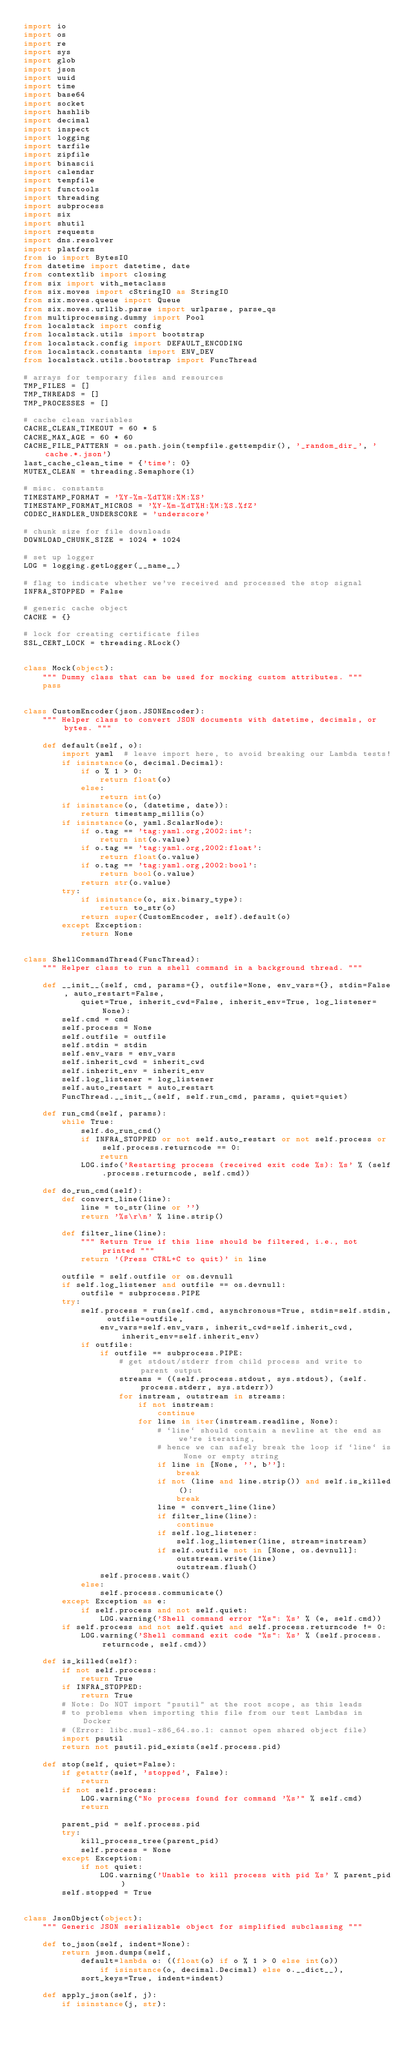Convert code to text. <code><loc_0><loc_0><loc_500><loc_500><_Python_>import io
import os
import re
import sys
import glob
import json
import uuid
import time
import base64
import socket
import hashlib
import decimal
import inspect
import logging
import tarfile
import zipfile
import binascii
import calendar
import tempfile
import functools
import threading
import subprocess
import six
import shutil
import requests
import dns.resolver
import platform
from io import BytesIO
from datetime import datetime, date
from contextlib import closing
from six import with_metaclass
from six.moves import cStringIO as StringIO
from six.moves.queue import Queue
from six.moves.urllib.parse import urlparse, parse_qs
from multiprocessing.dummy import Pool
from localstack import config
from localstack.utils import bootstrap
from localstack.config import DEFAULT_ENCODING
from localstack.constants import ENV_DEV
from localstack.utils.bootstrap import FuncThread

# arrays for temporary files and resources
TMP_FILES = []
TMP_THREADS = []
TMP_PROCESSES = []

# cache clean variables
CACHE_CLEAN_TIMEOUT = 60 * 5
CACHE_MAX_AGE = 60 * 60
CACHE_FILE_PATTERN = os.path.join(tempfile.gettempdir(), '_random_dir_', 'cache.*.json')
last_cache_clean_time = {'time': 0}
MUTEX_CLEAN = threading.Semaphore(1)

# misc. constants
TIMESTAMP_FORMAT = '%Y-%m-%dT%H:%M:%S'
TIMESTAMP_FORMAT_MICROS = '%Y-%m-%dT%H:%M:%S.%fZ'
CODEC_HANDLER_UNDERSCORE = 'underscore'

# chunk size for file downloads
DOWNLOAD_CHUNK_SIZE = 1024 * 1024

# set up logger
LOG = logging.getLogger(__name__)

# flag to indicate whether we've received and processed the stop signal
INFRA_STOPPED = False

# generic cache object
CACHE = {}

# lock for creating certificate files
SSL_CERT_LOCK = threading.RLock()


class Mock(object):
    """ Dummy class that can be used for mocking custom attributes. """
    pass


class CustomEncoder(json.JSONEncoder):
    """ Helper class to convert JSON documents with datetime, decimals, or bytes. """

    def default(self, o):
        import yaml  # leave import here, to avoid breaking our Lambda tests!
        if isinstance(o, decimal.Decimal):
            if o % 1 > 0:
                return float(o)
            else:
                return int(o)
        if isinstance(o, (datetime, date)):
            return timestamp_millis(o)
        if isinstance(o, yaml.ScalarNode):
            if o.tag == 'tag:yaml.org,2002:int':
                return int(o.value)
            if o.tag == 'tag:yaml.org,2002:float':
                return float(o.value)
            if o.tag == 'tag:yaml.org,2002:bool':
                return bool(o.value)
            return str(o.value)
        try:
            if isinstance(o, six.binary_type):
                return to_str(o)
            return super(CustomEncoder, self).default(o)
        except Exception:
            return None


class ShellCommandThread(FuncThread):
    """ Helper class to run a shell command in a background thread. """

    def __init__(self, cmd, params={}, outfile=None, env_vars={}, stdin=False, auto_restart=False,
            quiet=True, inherit_cwd=False, inherit_env=True, log_listener=None):
        self.cmd = cmd
        self.process = None
        self.outfile = outfile
        self.stdin = stdin
        self.env_vars = env_vars
        self.inherit_cwd = inherit_cwd
        self.inherit_env = inherit_env
        self.log_listener = log_listener
        self.auto_restart = auto_restart
        FuncThread.__init__(self, self.run_cmd, params, quiet=quiet)

    def run_cmd(self, params):
        while True:
            self.do_run_cmd()
            if INFRA_STOPPED or not self.auto_restart or not self.process or self.process.returncode == 0:
                return
            LOG.info('Restarting process (received exit code %s): %s' % (self.process.returncode, self.cmd))

    def do_run_cmd(self):
        def convert_line(line):
            line = to_str(line or '')
            return '%s\r\n' % line.strip()

        def filter_line(line):
            """ Return True if this line should be filtered, i.e., not printed """
            return '(Press CTRL+C to quit)' in line

        outfile = self.outfile or os.devnull
        if self.log_listener and outfile == os.devnull:
            outfile = subprocess.PIPE
        try:
            self.process = run(self.cmd, asynchronous=True, stdin=self.stdin, outfile=outfile,
                env_vars=self.env_vars, inherit_cwd=self.inherit_cwd, inherit_env=self.inherit_env)
            if outfile:
                if outfile == subprocess.PIPE:
                    # get stdout/stderr from child process and write to parent output
                    streams = ((self.process.stdout, sys.stdout), (self.process.stderr, sys.stderr))
                    for instream, outstream in streams:
                        if not instream:
                            continue
                        for line in iter(instream.readline, None):
                            # `line` should contain a newline at the end as we're iterating,
                            # hence we can safely break the loop if `line` is None or empty string
                            if line in [None, '', b'']:
                                break
                            if not (line and line.strip()) and self.is_killed():
                                break
                            line = convert_line(line)
                            if filter_line(line):
                                continue
                            if self.log_listener:
                                self.log_listener(line, stream=instream)
                            if self.outfile not in [None, os.devnull]:
                                outstream.write(line)
                                outstream.flush()
                self.process.wait()
            else:
                self.process.communicate()
        except Exception as e:
            if self.process and not self.quiet:
                LOG.warning('Shell command error "%s": %s' % (e, self.cmd))
        if self.process and not self.quiet and self.process.returncode != 0:
            LOG.warning('Shell command exit code "%s": %s' % (self.process.returncode, self.cmd))

    def is_killed(self):
        if not self.process:
            return True
        if INFRA_STOPPED:
            return True
        # Note: Do NOT import "psutil" at the root scope, as this leads
        # to problems when importing this file from our test Lambdas in Docker
        # (Error: libc.musl-x86_64.so.1: cannot open shared object file)
        import psutil
        return not psutil.pid_exists(self.process.pid)

    def stop(self, quiet=False):
        if getattr(self, 'stopped', False):
            return
        if not self.process:
            LOG.warning("No process found for command '%s'" % self.cmd)
            return

        parent_pid = self.process.pid
        try:
            kill_process_tree(parent_pid)
            self.process = None
        except Exception:
            if not quiet:
                LOG.warning('Unable to kill process with pid %s' % parent_pid)
        self.stopped = True


class JsonObject(object):
    """ Generic JSON serializable object for simplified subclassing """

    def to_json(self, indent=None):
        return json.dumps(self,
            default=lambda o: ((float(o) if o % 1 > 0 else int(o))
                if isinstance(o, decimal.Decimal) else o.__dict__),
            sort_keys=True, indent=indent)

    def apply_json(self, j):
        if isinstance(j, str):</code> 